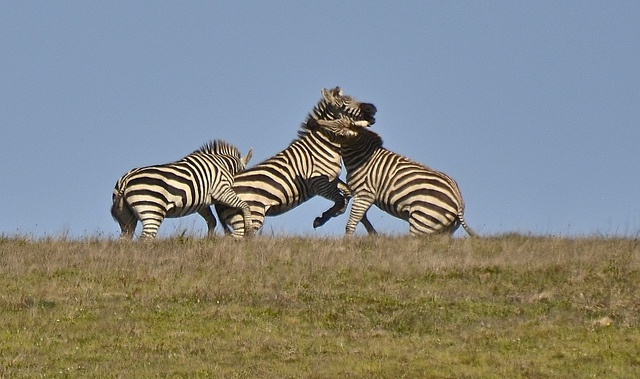Describe the objects in this image and their specific colors. I can see zebra in darkgray, black, tan, and maroon tones, zebra in darkgray, black, tan, and gray tones, and zebra in darkgray, black, tan, beige, and gray tones in this image. 